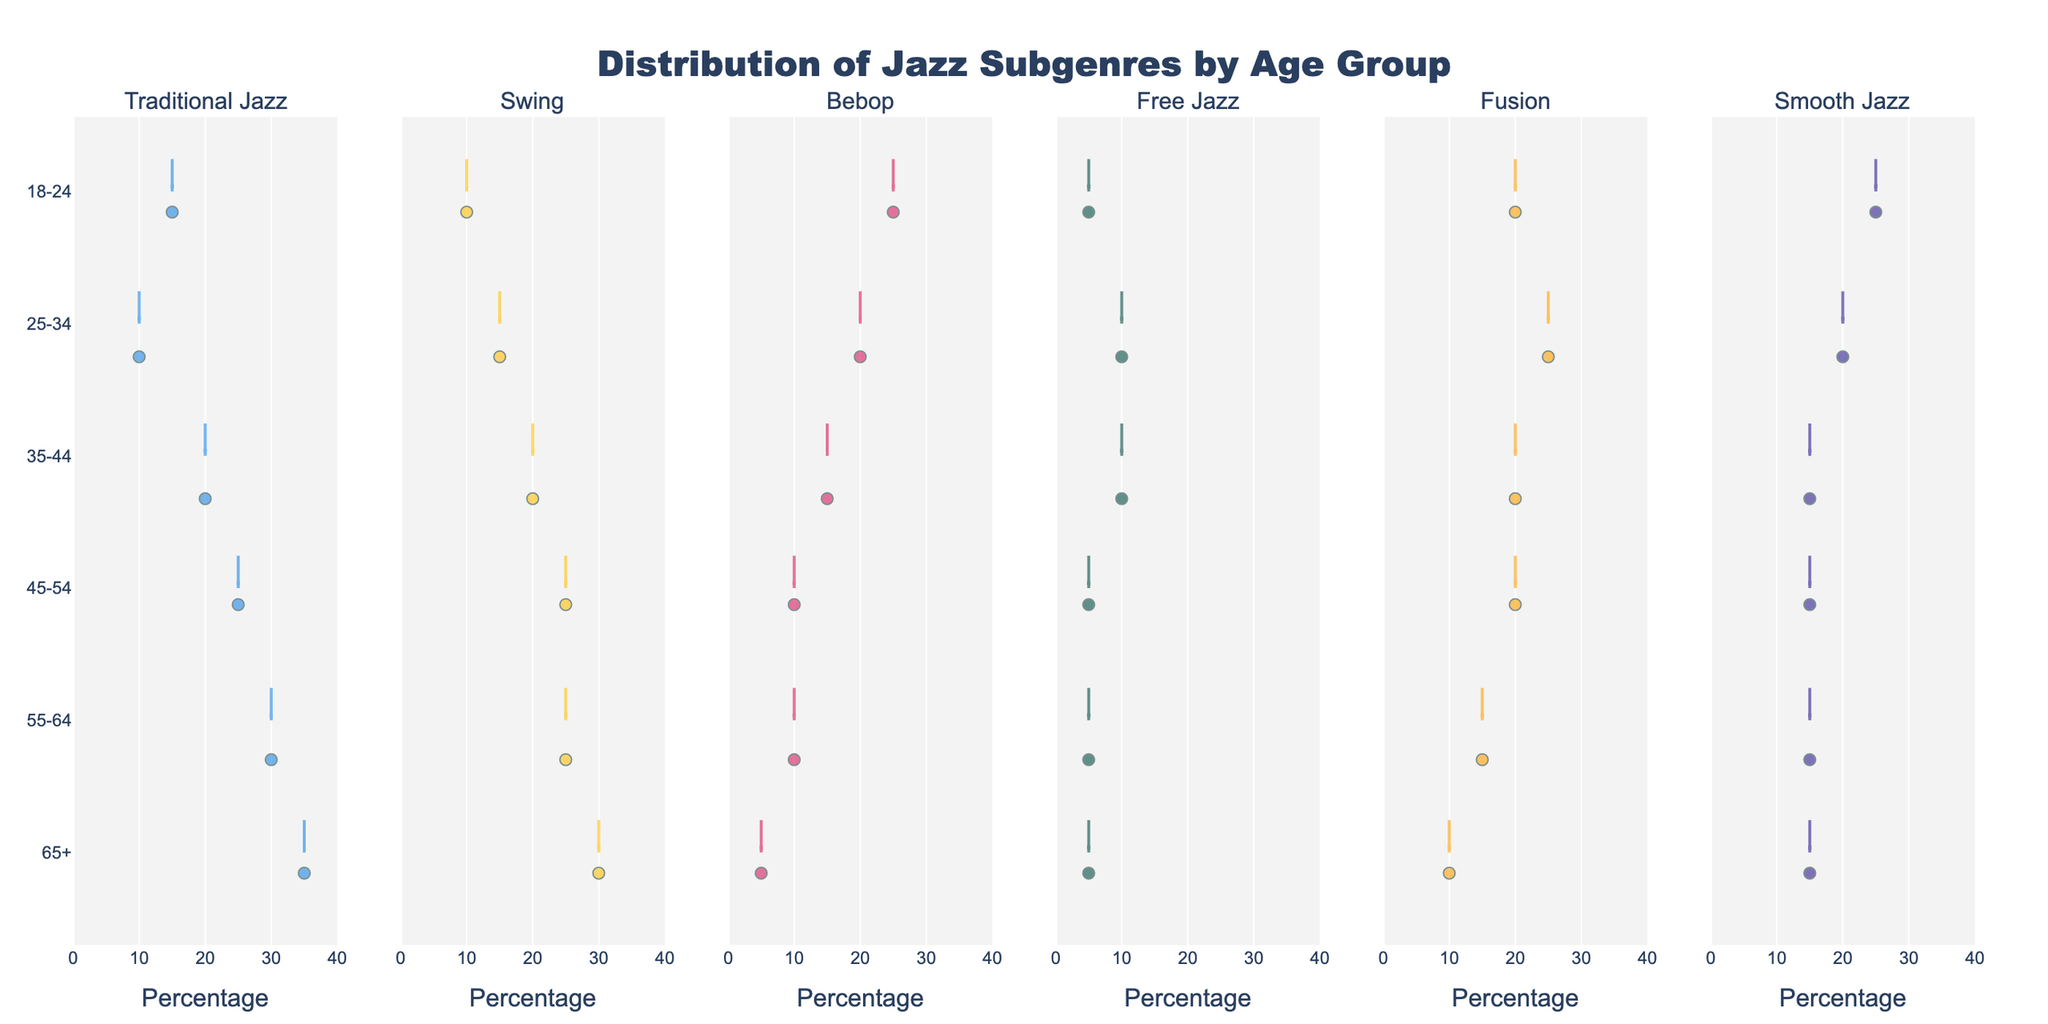What is the title of the figure? The title is usually placed at the top of the chart. The title states the primary information about the plot.
Answer: Distribution of Jazz Subgenres by Age Group Which age group listens to Smooth Jazz the most? Look at the violin for Smooth Jazz and identify the age group with the widest or highest percentage representation.
Answer: 18-24 What is the median percentage of Bebop listeners in the 25-34 age group? The median is the middle value of the percentage data points for Bebop in the 25-34 age group. Look for the location of the median line within the Bebop section for this age group.
Answer: 20 Compare the popularity of Swing between the 45-54 and 65+ age groups. Which has a higher percentage? Refer to the violins on the Swing subplot. Identify the positions of the percentage data points for both age groups.
Answer: 65+ Which jazz subgenre shows the least variation in listening percentages across all age groups? Variation can be judged by the width and spread of the violins. The subgenre with the narrowest or least spread violin shape across age groups indicates the least variation.
Answer: Free Jazz How does the percentage of Fusion listeners change from the youngest to the oldest age group? Look at the Fusion subplot and compare the percentage data points from the 18-24 age group through to the 65+ age group.
Answer: Decreases In the 55-64 age group, which jazz subgenre has the most balanced distribution? Balanced distribution can be identified by looking at how uniformly the data points are spread within the respective violin shape.
Answer: Traditional Jazz What range of percentages is shown on the x-axis? The range can be identified by looking at the x-axis values from the lowest to the highest point.
Answer: 0 to 40% Which two subgenres have the same median percentage for the 25-34 age group? Compare the median lines within the violins for the 25-34 age group across all subgenres.
Answer: Bebop and Smooth Jazz Between Traditional Jazz and Bebop, which has a higher percentage of listeners in the 35-44 age group? Locate the 35-44 age group within the violins for both Traditional Jazz and Bebop, and compare the percentage values.
Answer: Traditional Jazz 